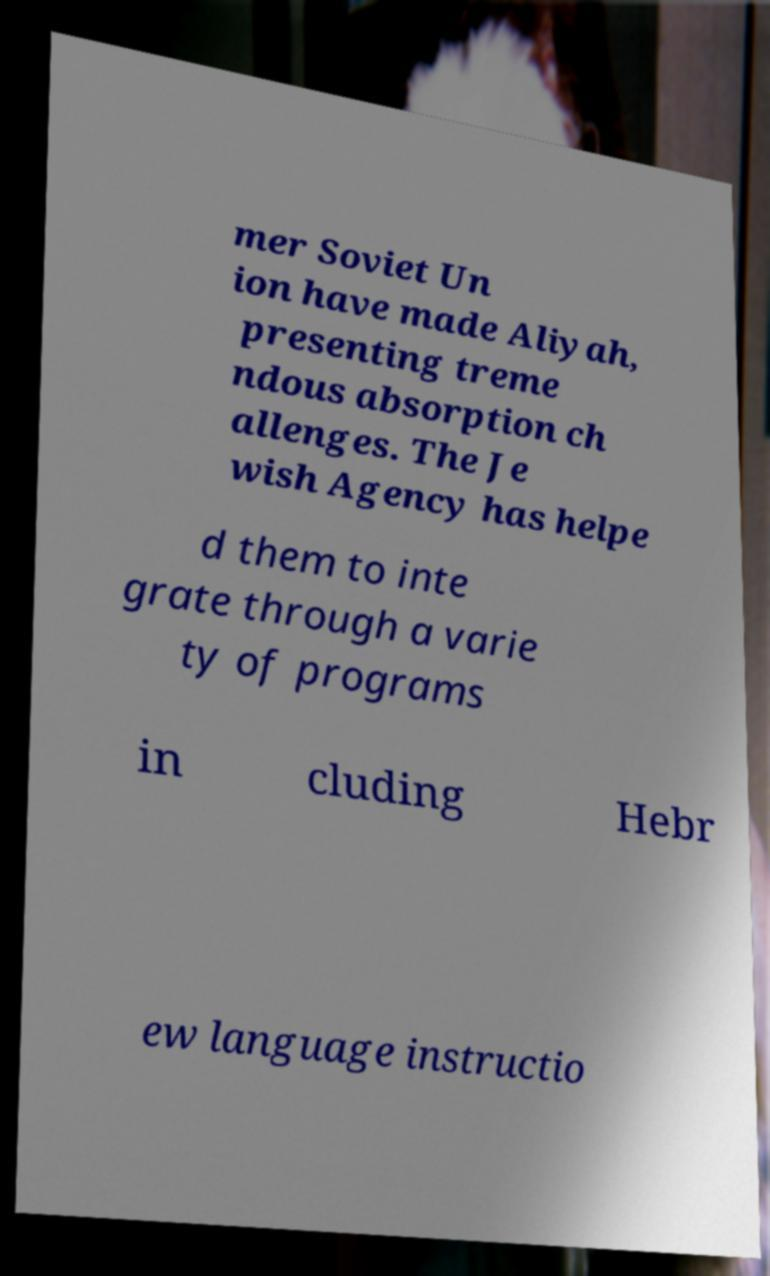What messages or text are displayed in this image? I need them in a readable, typed format. mer Soviet Un ion have made Aliyah, presenting treme ndous absorption ch allenges. The Je wish Agency has helpe d them to inte grate through a varie ty of programs in cluding Hebr ew language instructio 